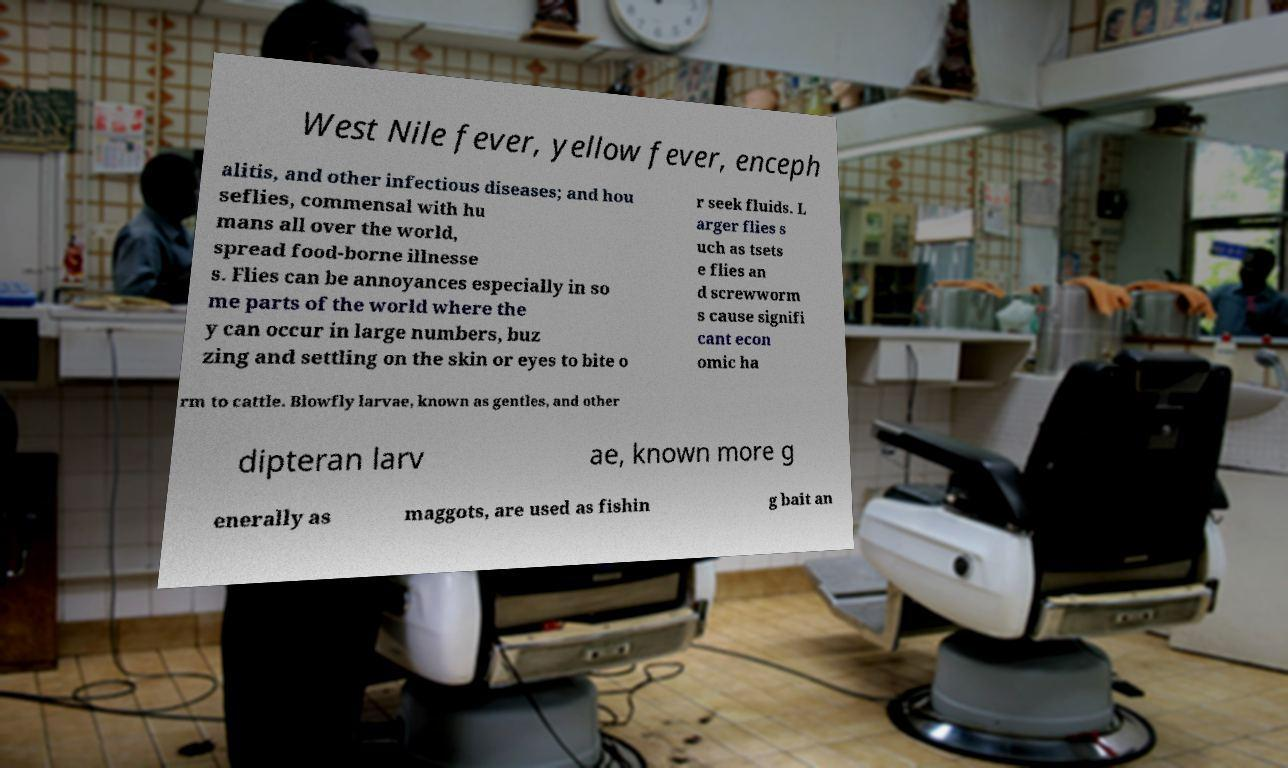Could you assist in decoding the text presented in this image and type it out clearly? West Nile fever, yellow fever, enceph alitis, and other infectious diseases; and hou seflies, commensal with hu mans all over the world, spread food-borne illnesse s. Flies can be annoyances especially in so me parts of the world where the y can occur in large numbers, buz zing and settling on the skin or eyes to bite o r seek fluids. L arger flies s uch as tsets e flies an d screwworm s cause signifi cant econ omic ha rm to cattle. Blowfly larvae, known as gentles, and other dipteran larv ae, known more g enerally as maggots, are used as fishin g bait an 